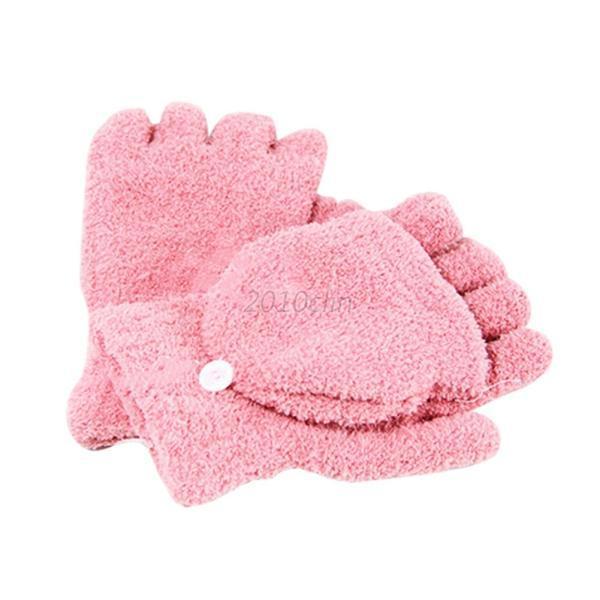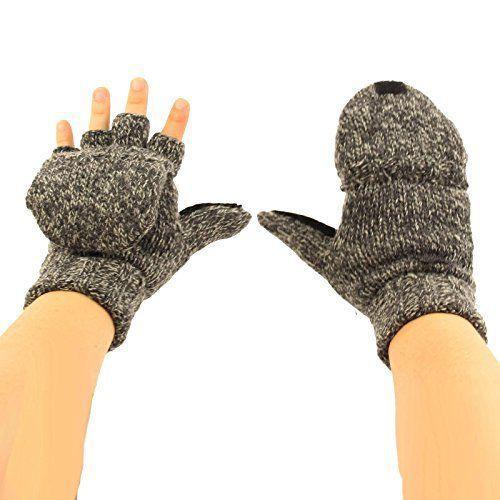The first image is the image on the left, the second image is the image on the right. Given the left and right images, does the statement "The left image shows a pair of pink half-finger gloves with a mitten flap, and the right shows the same type of fashion in heather yarn, but only one shows gloves worn by hands." hold true? Answer yes or no. Yes. The first image is the image on the left, the second image is the image on the right. Considering the images on both sides, is "There is a set of pink convertible mittens in one image." valid? Answer yes or no. Yes. 